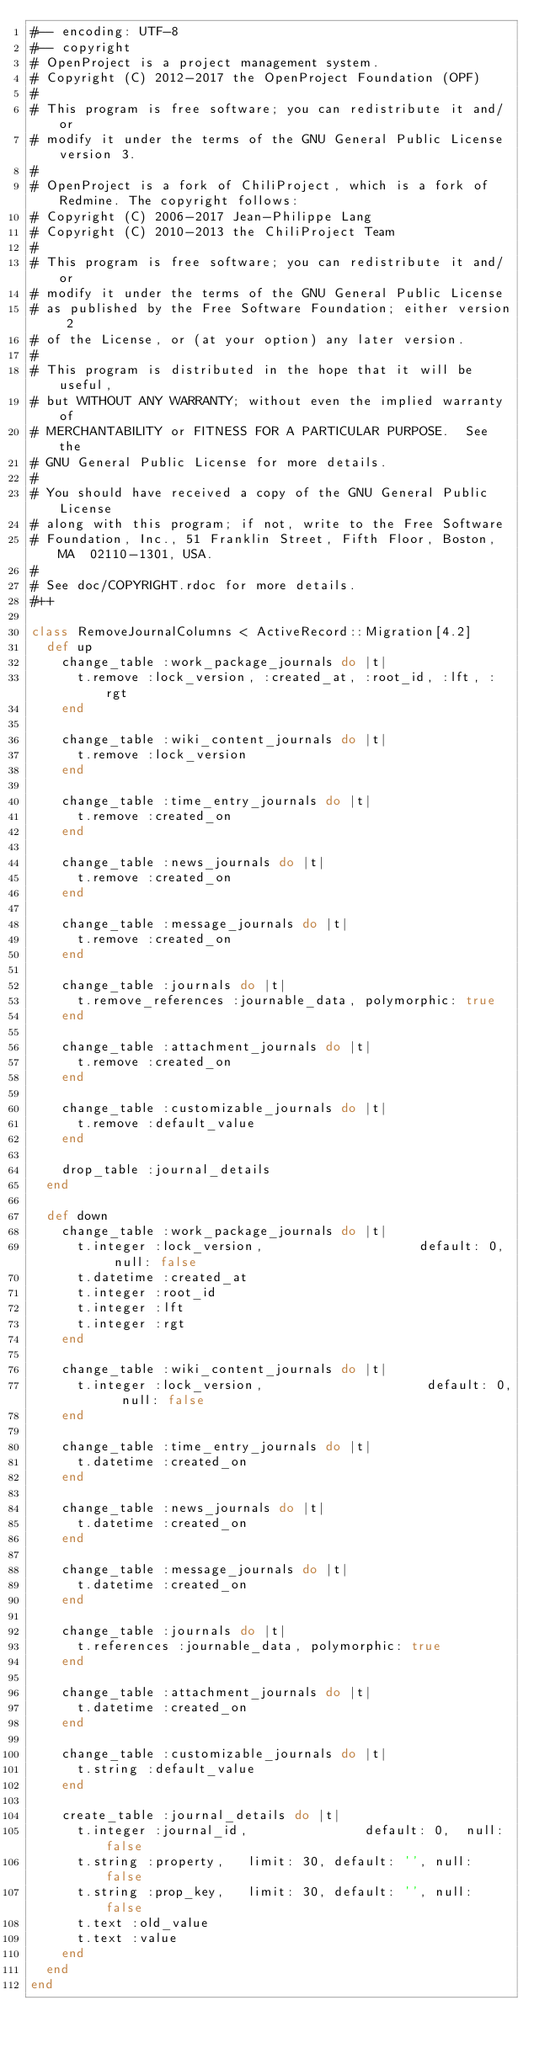Convert code to text. <code><loc_0><loc_0><loc_500><loc_500><_Ruby_>#-- encoding: UTF-8
#-- copyright
# OpenProject is a project management system.
# Copyright (C) 2012-2017 the OpenProject Foundation (OPF)
#
# This program is free software; you can redistribute it and/or
# modify it under the terms of the GNU General Public License version 3.
#
# OpenProject is a fork of ChiliProject, which is a fork of Redmine. The copyright follows:
# Copyright (C) 2006-2017 Jean-Philippe Lang
# Copyright (C) 2010-2013 the ChiliProject Team
#
# This program is free software; you can redistribute it and/or
# modify it under the terms of the GNU General Public License
# as published by the Free Software Foundation; either version 2
# of the License, or (at your option) any later version.
#
# This program is distributed in the hope that it will be useful,
# but WITHOUT ANY WARRANTY; without even the implied warranty of
# MERCHANTABILITY or FITNESS FOR A PARTICULAR PURPOSE.  See the
# GNU General Public License for more details.
#
# You should have received a copy of the GNU General Public License
# along with this program; if not, write to the Free Software
# Foundation, Inc., 51 Franklin Street, Fifth Floor, Boston, MA  02110-1301, USA.
#
# See doc/COPYRIGHT.rdoc for more details.
#++

class RemoveJournalColumns < ActiveRecord::Migration[4.2]
  def up
    change_table :work_package_journals do |t|
      t.remove :lock_version, :created_at, :root_id, :lft, :rgt
    end

    change_table :wiki_content_journals do |t|
      t.remove :lock_version
    end

    change_table :time_entry_journals do |t|
      t.remove :created_on
    end

    change_table :news_journals do |t|
      t.remove :created_on
    end

    change_table :message_journals do |t|
      t.remove :created_on
    end

    change_table :journals do |t|
      t.remove_references :journable_data, polymorphic: true
    end

    change_table :attachment_journals do |t|
      t.remove :created_on
    end

    change_table :customizable_journals do |t|
      t.remove :default_value
    end

    drop_table :journal_details
  end

  def down
    change_table :work_package_journals do |t|
      t.integer :lock_version,                    default: 0,  null: false
      t.datetime :created_at
      t.integer :root_id
      t.integer :lft
      t.integer :rgt
    end

    change_table :wiki_content_journals do |t|
      t.integer :lock_version,                     default: 0,  null: false
    end

    change_table :time_entry_journals do |t|
      t.datetime :created_on
    end

    change_table :news_journals do |t|
      t.datetime :created_on
    end

    change_table :message_journals do |t|
      t.datetime :created_on
    end

    change_table :journals do |t|
      t.references :journable_data, polymorphic: true
    end

    change_table :attachment_journals do |t|
      t.datetime :created_on
    end

    change_table :customizable_journals do |t|
      t.string :default_value
    end

    create_table :journal_details do |t|
      t.integer :journal_id,               default: 0,  null: false
      t.string :property,   limit: 30, default: '', null: false
      t.string :prop_key,   limit: 30, default: '', null: false
      t.text :old_value
      t.text :value
    end
  end
end
</code> 